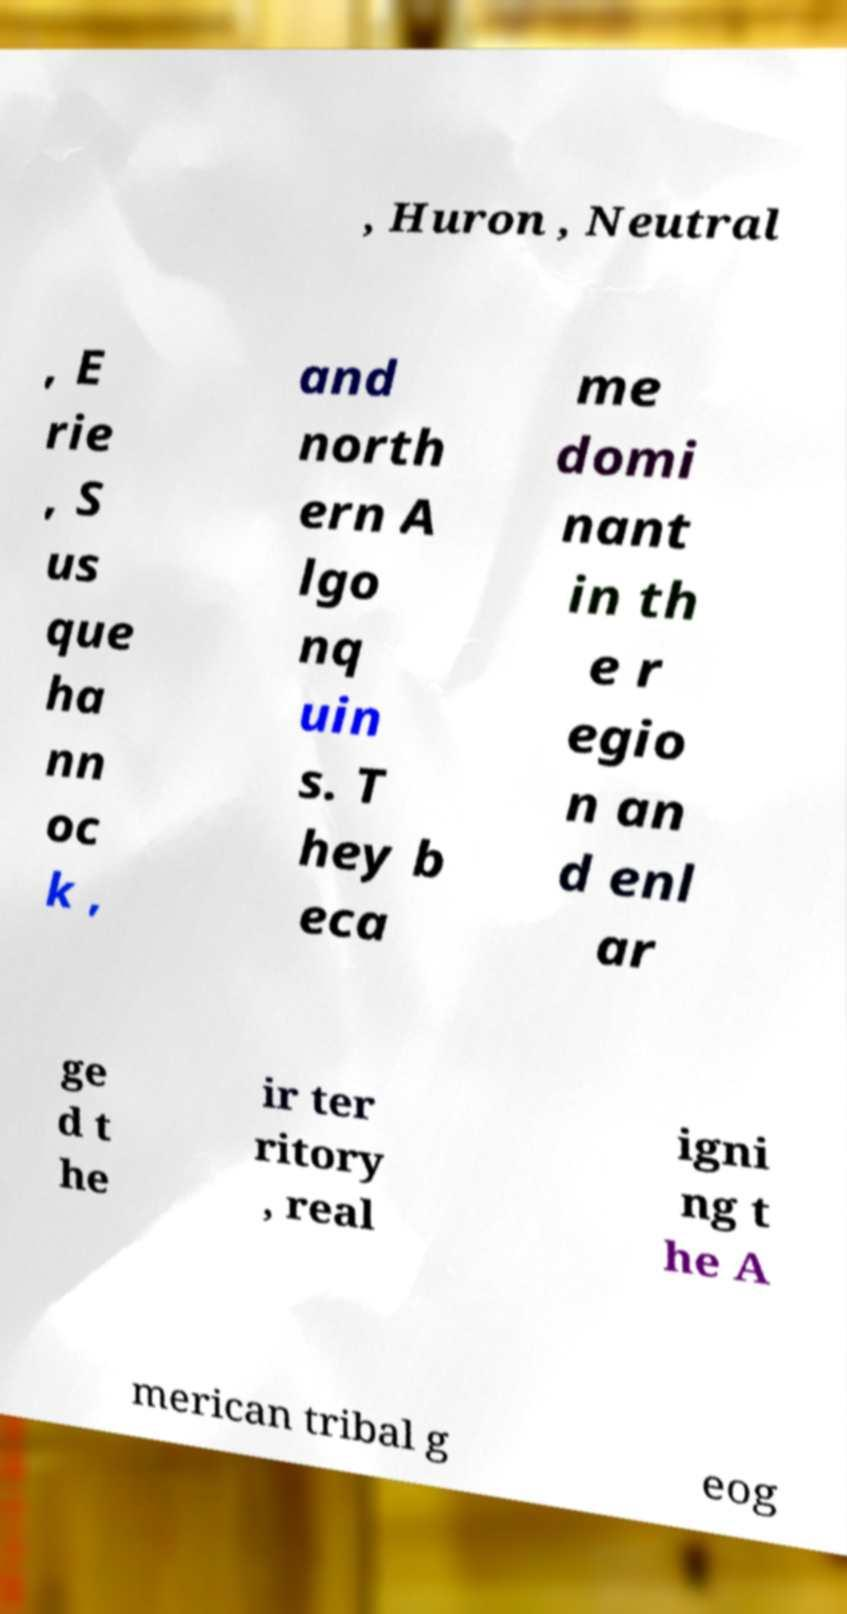Please read and relay the text visible in this image. What does it say? , Huron , Neutral , E rie , S us que ha nn oc k , and north ern A lgo nq uin s. T hey b eca me domi nant in th e r egio n an d enl ar ge d t he ir ter ritory , real igni ng t he A merican tribal g eog 